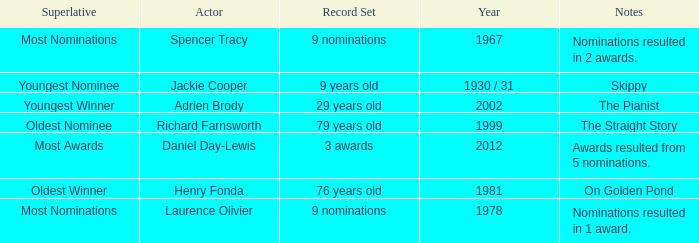What actor won in 1978? Laurence Olivier. 